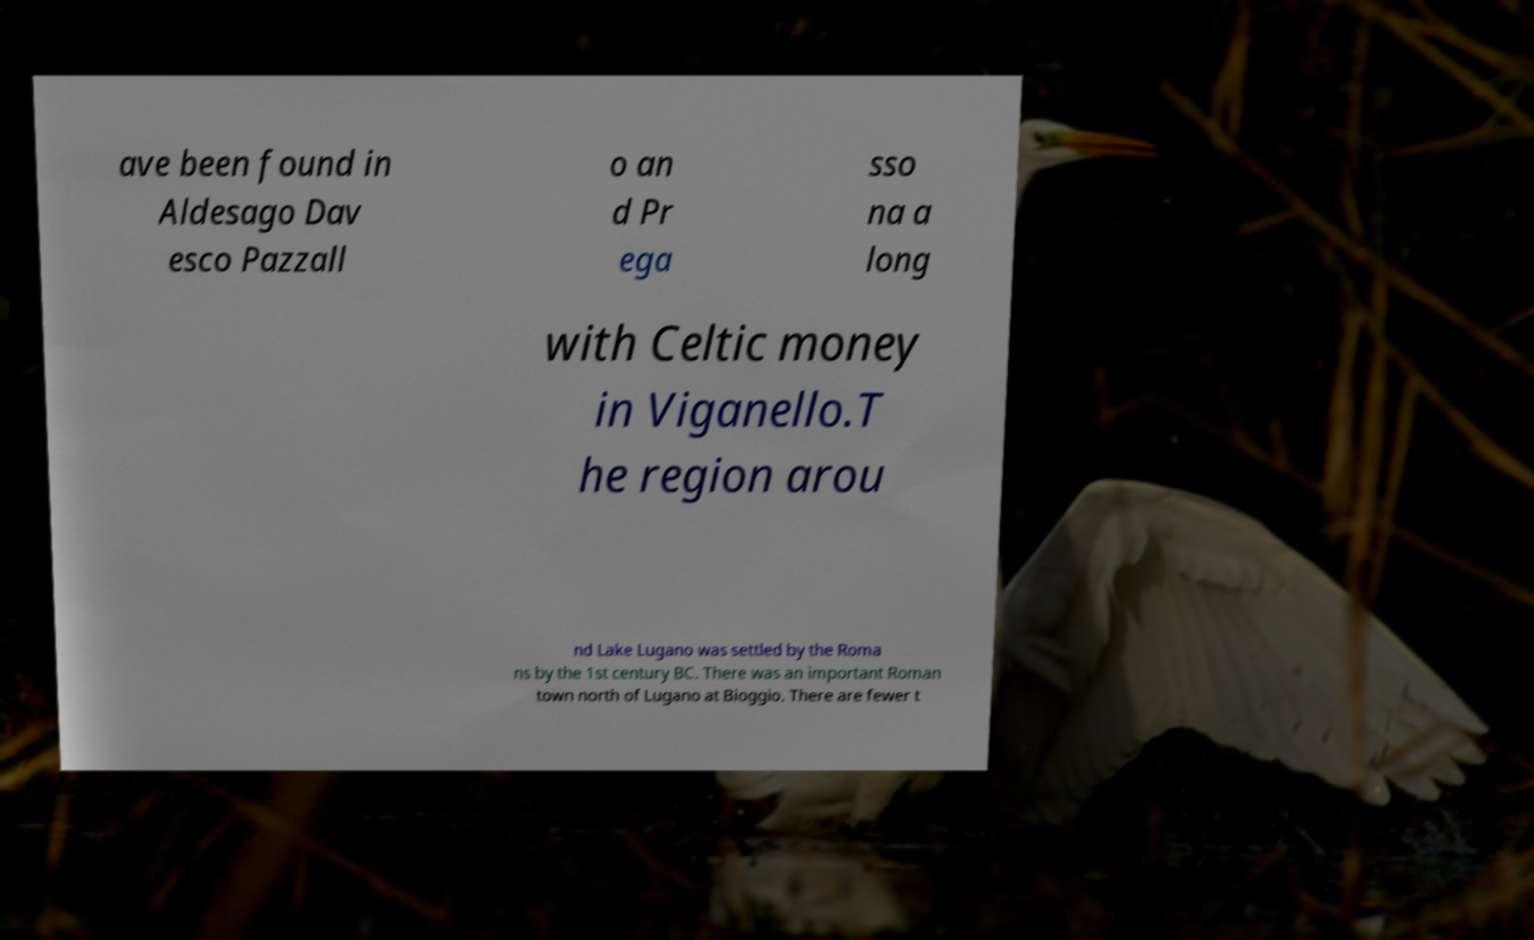For documentation purposes, I need the text within this image transcribed. Could you provide that? ave been found in Aldesago Dav esco Pazzall o an d Pr ega sso na a long with Celtic money in Viganello.T he region arou nd Lake Lugano was settled by the Roma ns by the 1st century BC. There was an important Roman town north of Lugano at Bioggio. There are fewer t 